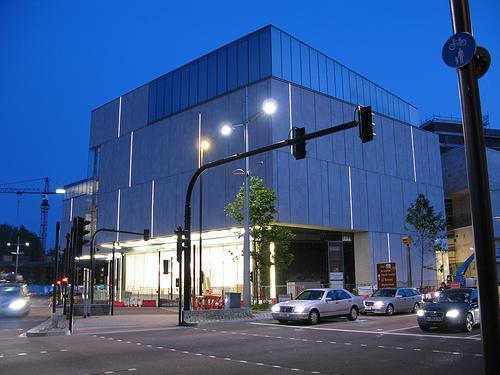How many cars can be seen?
Give a very brief answer. 4. 